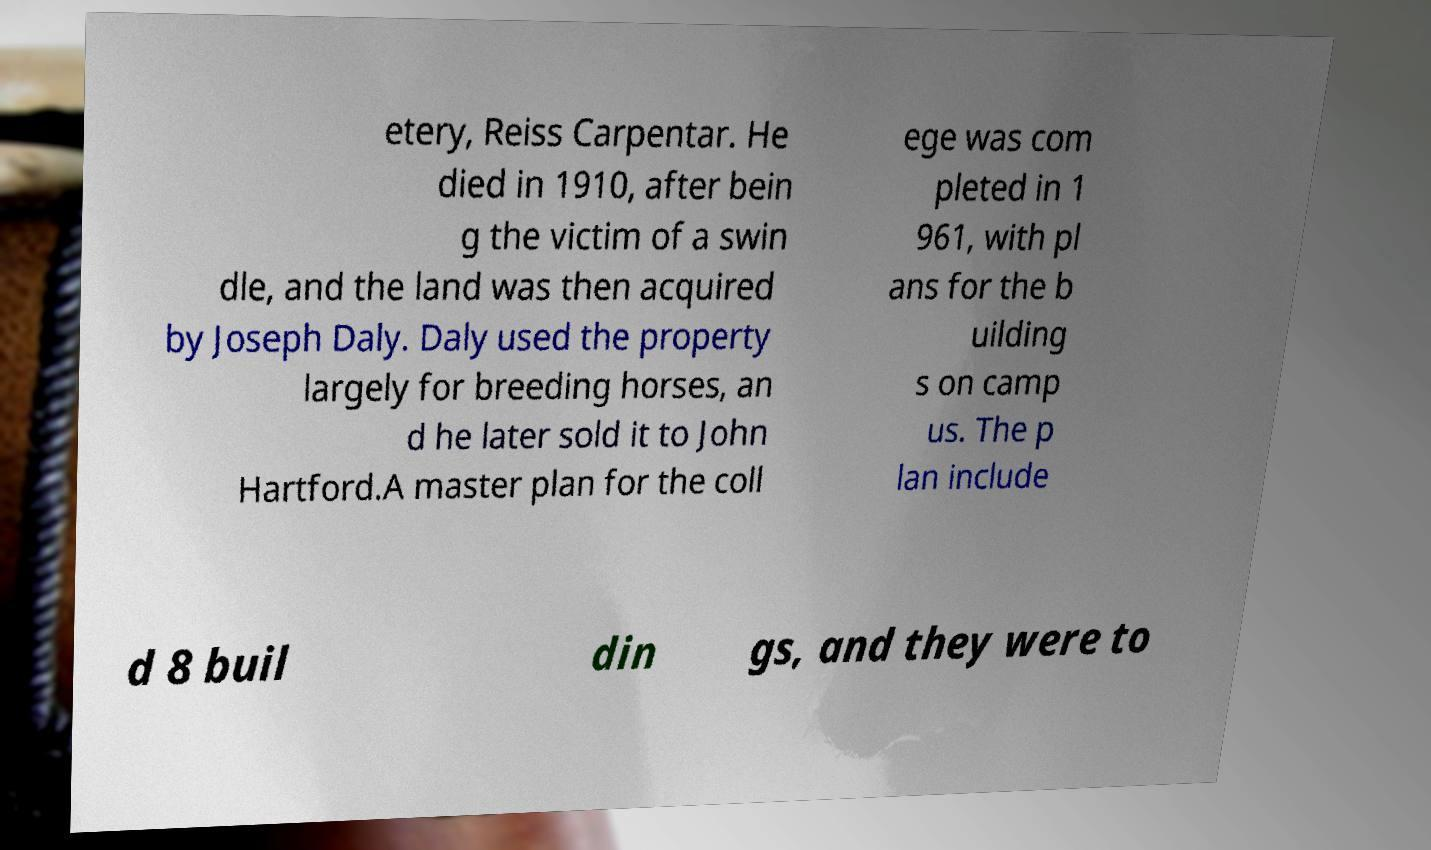Can you read and provide the text displayed in the image?This photo seems to have some interesting text. Can you extract and type it out for me? etery, Reiss Carpentar. He died in 1910, after bein g the victim of a swin dle, and the land was then acquired by Joseph Daly. Daly used the property largely for breeding horses, an d he later sold it to John Hartford.A master plan for the coll ege was com pleted in 1 961, with pl ans for the b uilding s on camp us. The p lan include d 8 buil din gs, and they were to 